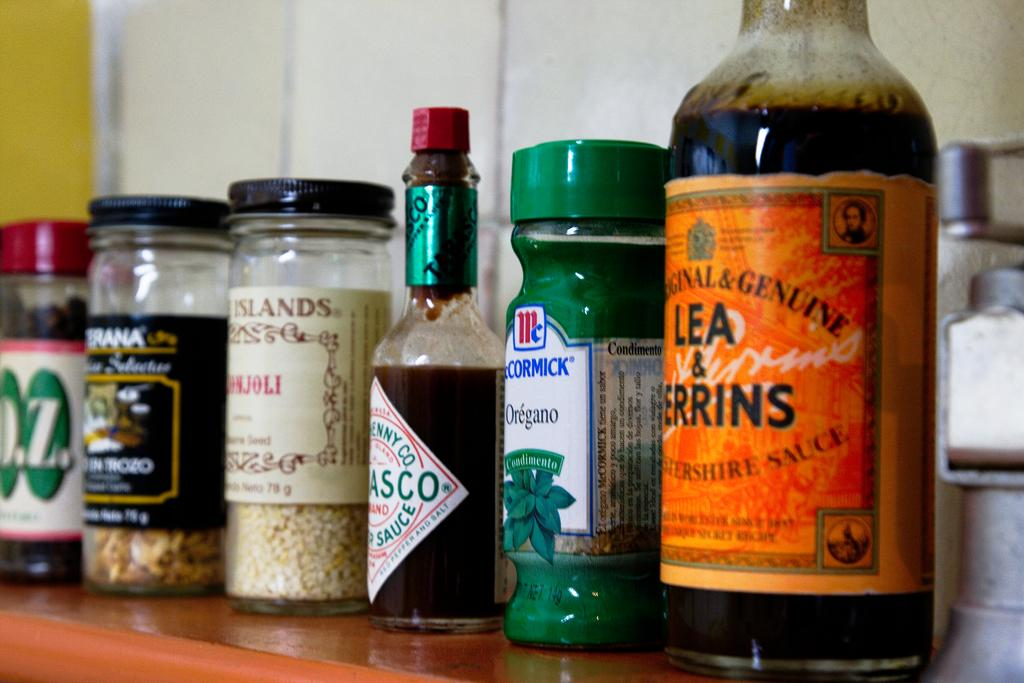<image>
Present a compact description of the photo's key features. A container of McCormick oregano is next to a Lea and Perrins. 